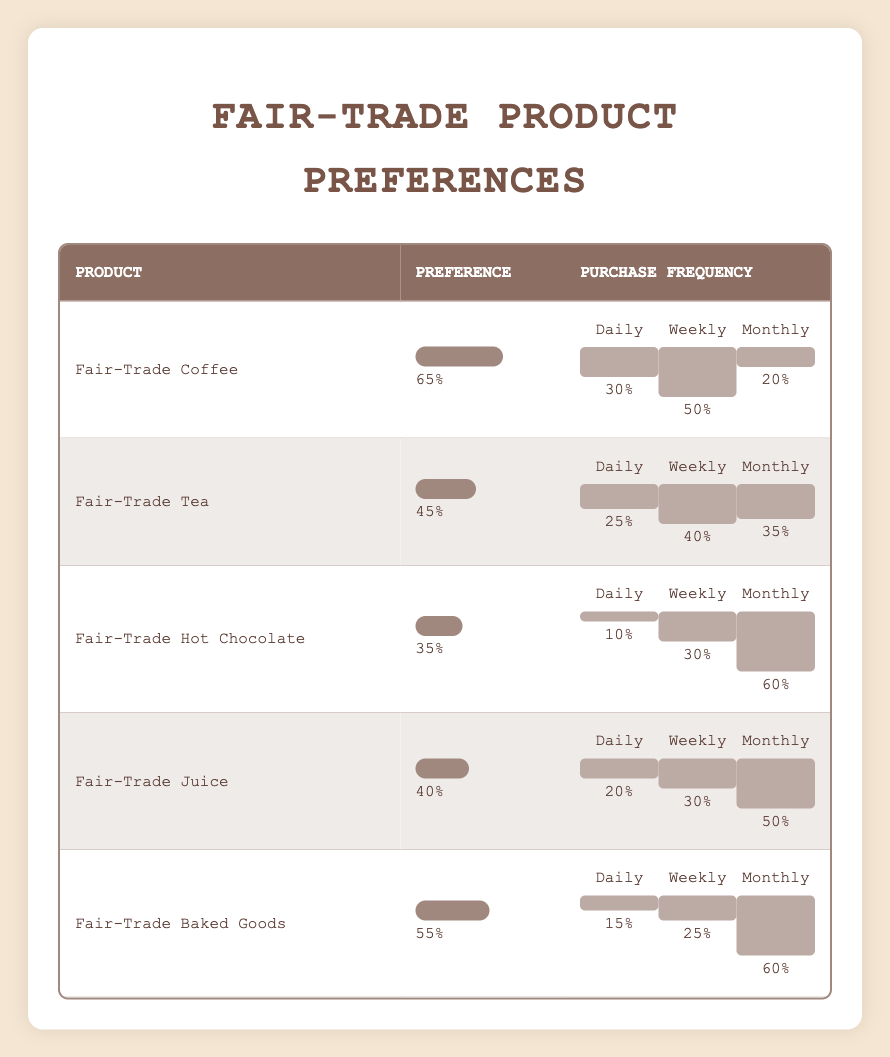What is the preference percentage for Fair-Trade Coffee? Referring to the table, Fair-Trade Coffee has a preference percentage listed directly in the corresponding row, which is 65%.
Answer: 65% Which fair-trade product has the highest preference percentage? Comparing the preference percentages listed, Fair-Trade Coffee (65%) has the highest preference compared to the others like Tea (45%), Hot Chocolate (35%), Juice (40%), and Baked Goods (55%).
Answer: Fair-Trade Coffee What is the purchase frequency percentage for Fair-Trade Juice on a monthly basis? Looking at the row for Fair-Trade Juice, the table indicates that the monthly purchase frequency percentage is 50%.
Answer: 50% Are customers more likely to purchase Fair-Trade Tea weekly or monthly? For Fair-Trade Tea, the weekly purchase frequency is 40%, while the monthly purchase frequency is 35%. Since 40% is greater than 35%, customers are more likely to purchase it weekly.
Answer: Yes What is the overall average preference percentage of all listed Fair-Trade products? To find the average preference percentage, add the percentages (65 + 45 + 35 + 40 + 55) which equals 240. Divide by the number of products, which is 5. Thus, the average is 240/5 = 48.
Answer: 48 Which product has the lowest daily purchase frequency, and what is that percentage? The product with the lowest daily purchase frequency can be identified by checking each product's daily frequency. Fair-Trade Hot Chocolate has a daily purchase frequency of 10%, which is the lowest among the options.
Answer: Fair-Trade Hot Chocolate, 10% How many products have a preference percentage below 45%? By inspecting the preference percentages, Fair-Trade Hot Chocolate (35%) and Fair-Trade Tea (45%) have percentages below or equal to 45%. Therefore, there are two products.
Answer: 2 Is the monthly purchase frequency for Fair-Trade Baked Goods greater than that for Fair-Trade Hot Chocolate? For Fair-Trade Baked Goods, the monthly purchase frequency is 60%, whereas for Fair-Trade Hot Chocolate, it is 60% as well. Since they are equal, the answer is no.
Answer: No What is the difference in percentage between the weekly purchase frequency of Fair-Trade Coffee and Fair-Trade Baked Goods? Fair-Trade Coffee has a weekly purchase frequency of 50%, and Fair-Trade Baked Goods has 25%. The difference is 50% - 25% = 25%.
Answer: 25% 